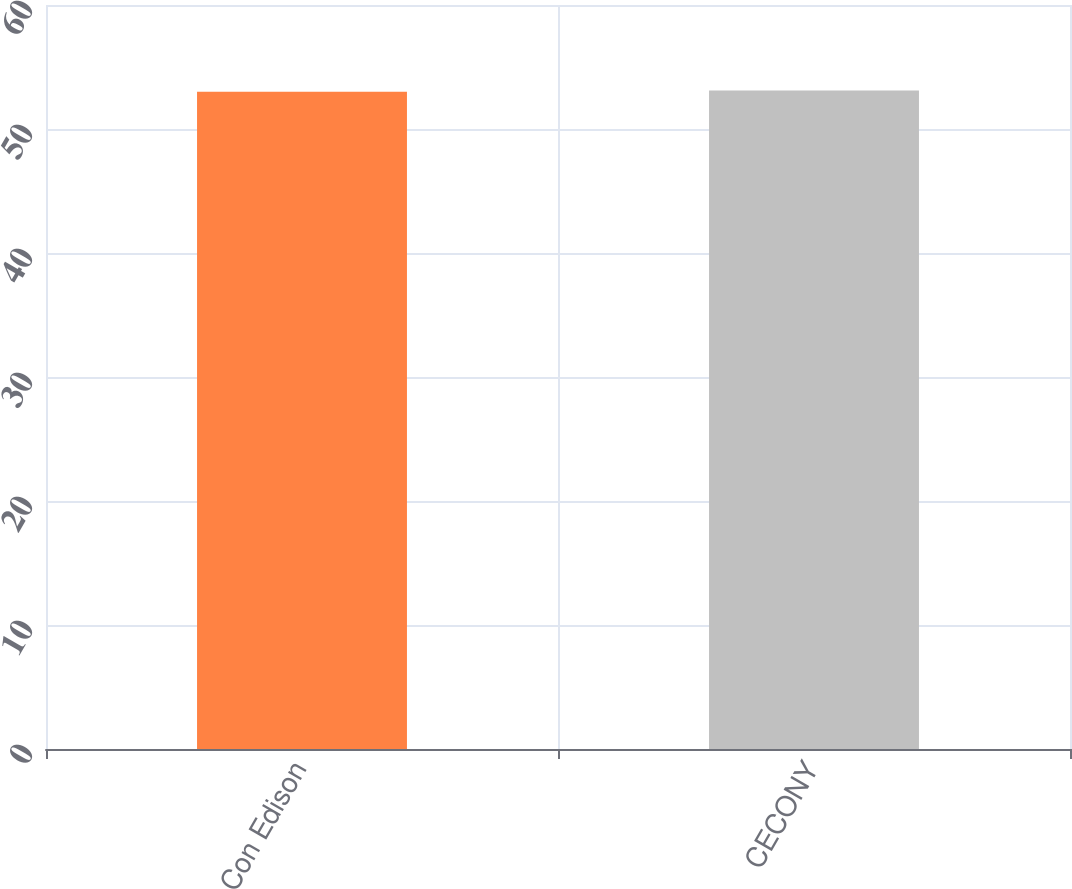Convert chart to OTSL. <chart><loc_0><loc_0><loc_500><loc_500><bar_chart><fcel>Con Edison<fcel>CECONY<nl><fcel>53<fcel>53.1<nl></chart> 